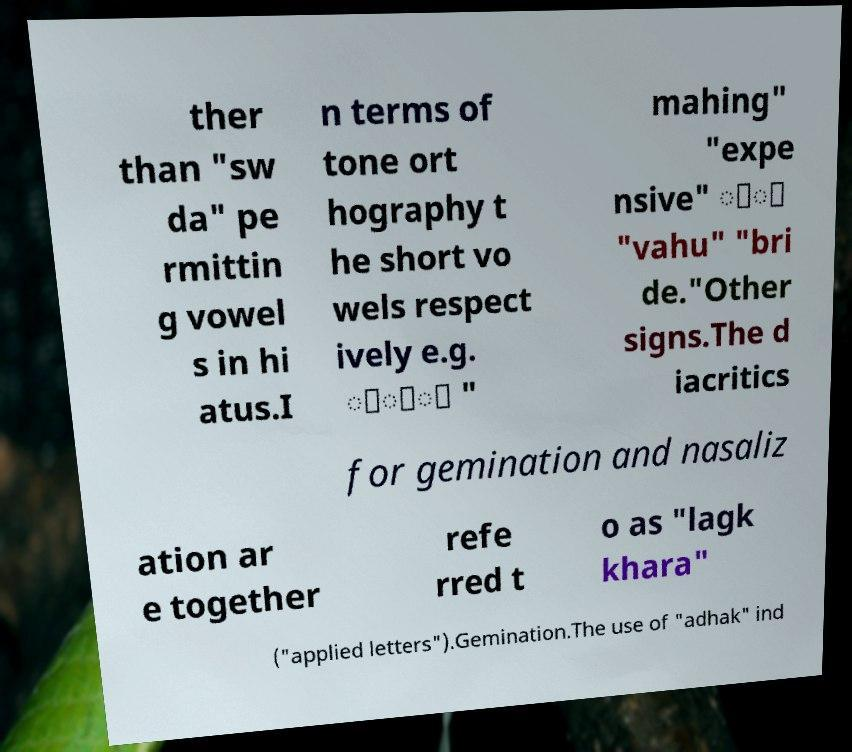Can you accurately transcribe the text from the provided image for me? ther than "sw da" pe rmittin g vowel s in hi atus.I n terms of tone ort hography t he short vo wels respect ively e.g. ਿੰਾ " mahing" "expe nsive" ੁੀ "vahu" "bri de."Other signs.The d iacritics for gemination and nasaliz ation ar e together refe rred t o as "lagk khara" ("applied letters").Gemination.The use of "adhak" ind 